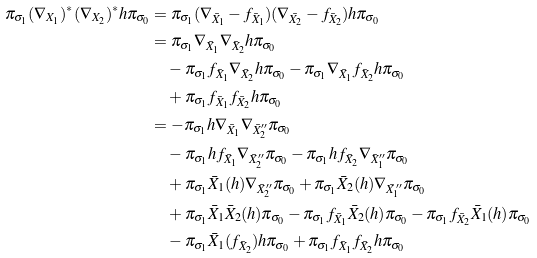<formula> <loc_0><loc_0><loc_500><loc_500>\pi _ { \sigma _ { 1 } } ( \nabla _ { X _ { 1 } } ) ^ { * } ( \nabla _ { X _ { 2 } } ) ^ { * } h \pi _ { \sigma _ { 0 } } & = \pi _ { \sigma _ { 1 } } ( \nabla _ { \bar { X } _ { 1 } } - f _ { \bar { X } _ { 1 } } ) ( \nabla _ { \bar { X } _ { 2 } } - f _ { \bar { X } _ { 2 } } ) h \pi _ { \sigma _ { 0 } } \\ & = \pi _ { \sigma _ { 1 } } \nabla _ { \bar { X } _ { 1 } } \nabla _ { \bar { X } _ { 2 } } h \pi _ { \sigma _ { 0 } } \\ & \quad - \pi _ { \sigma _ { 1 } } f _ { \bar { X } _ { 1 } } \nabla _ { \bar { X } _ { 2 } } h \pi _ { \sigma _ { 0 } } - \pi _ { \sigma _ { 1 } } \nabla _ { \bar { X } _ { 1 } } f _ { \bar { X } _ { 2 } } h \pi _ { \sigma _ { 0 } } \\ & \quad + \pi _ { \sigma _ { 1 } } f _ { \bar { X } _ { 1 } } f _ { \bar { X } _ { 2 } } h \pi _ { \sigma _ { 0 } } \\ & = - \pi _ { \sigma _ { 1 } } h \nabla _ { \bar { X } _ { 1 } } \nabla _ { \bar { X } ^ { \prime \prime } _ { 2 } } \pi _ { \sigma _ { 0 } } \\ & \quad - \pi _ { \sigma _ { 1 } } h f _ { \bar { X } _ { 1 } } \nabla _ { \bar { X } ^ { \prime \prime } _ { 2 } } \pi _ { \sigma _ { 0 } } - \pi _ { \sigma _ { 1 } } h f _ { \bar { X } _ { 2 } } \nabla _ { \bar { X } ^ { \prime \prime } _ { 1 } } \pi _ { \sigma _ { 0 } } \\ & \quad + \pi _ { \sigma _ { 1 } } \bar { X } _ { 1 } ( h ) \nabla _ { \bar { X } ^ { \prime \prime } _ { 2 } } \pi _ { \sigma _ { 0 } } + \pi _ { \sigma _ { 1 } } \bar { X } _ { 2 } ( h ) \nabla _ { \bar { X } ^ { \prime \prime } _ { 1 } } \pi _ { \sigma _ { 0 } } \\ & \quad + \pi _ { \sigma _ { 1 } } \bar { X } _ { 1 } \bar { X } _ { 2 } ( h ) \pi _ { \sigma _ { 0 } } - \pi _ { \sigma _ { 1 } } f _ { \bar { X } _ { 1 } } \bar { X } _ { 2 } ( h ) \pi _ { \sigma _ { 0 } } - \pi _ { \sigma _ { 1 } } f _ { \bar { X } _ { 2 } } \bar { X } _ { 1 } ( h ) \pi _ { \sigma _ { 0 } } \\ & \quad - \pi _ { \sigma _ { 1 } } \bar { X } _ { 1 } ( f _ { \bar { X } _ { 2 } } ) h \pi _ { \sigma _ { 0 } } + \pi _ { \sigma _ { 1 } } f _ { \bar { X } _ { 1 } } f _ { \bar { X } _ { 2 } } h \pi _ { \sigma _ { 0 } }</formula> 